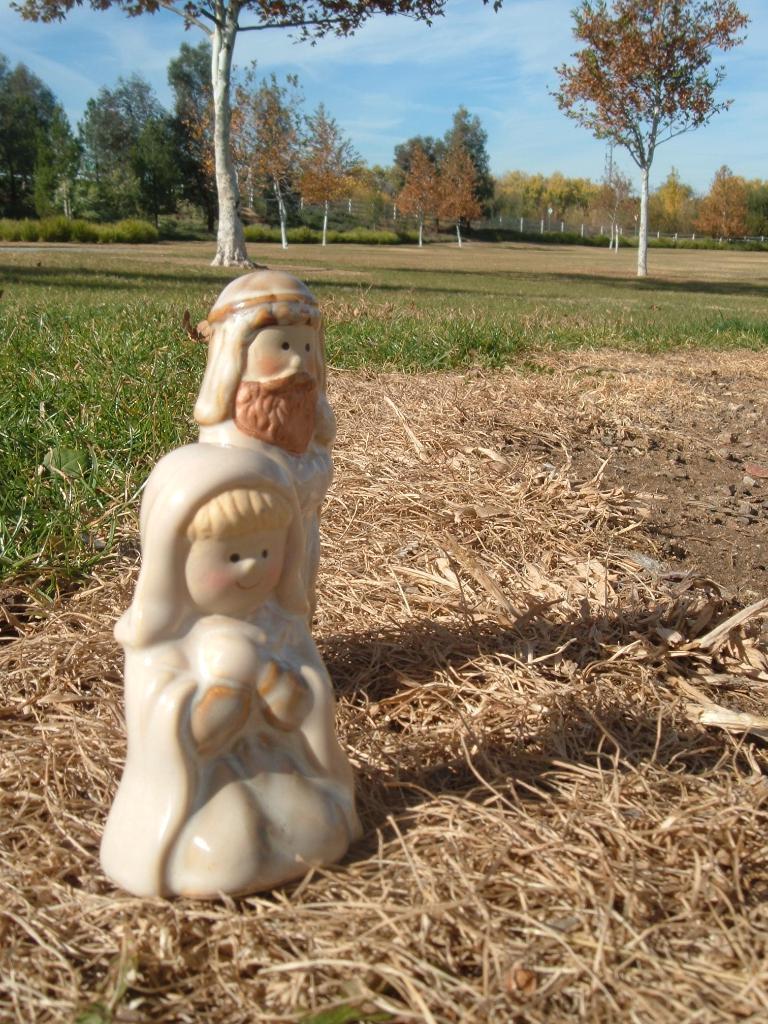How would you summarize this image in a sentence or two? In this image there is a statue on the dry grass. In the background there is a ground in which there are trees. At the top there is the sky. At the bottom there is dry grass. 